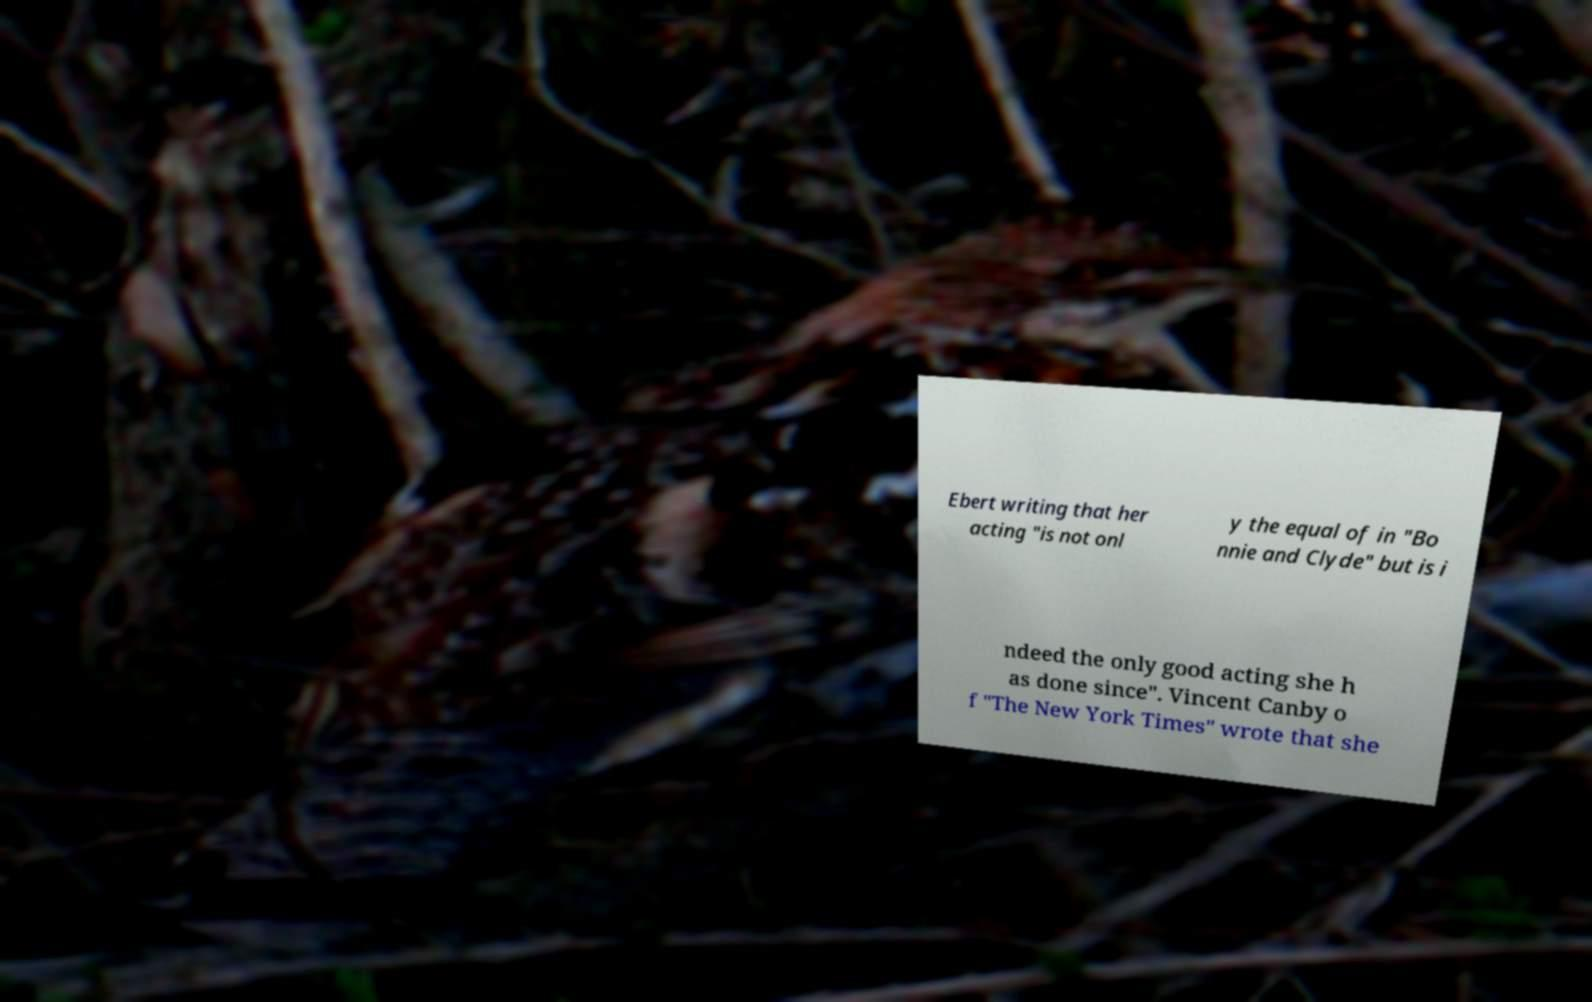Please identify and transcribe the text found in this image. Ebert writing that her acting "is not onl y the equal of in "Bo nnie and Clyde" but is i ndeed the only good acting she h as done since". Vincent Canby o f "The New York Times" wrote that she 